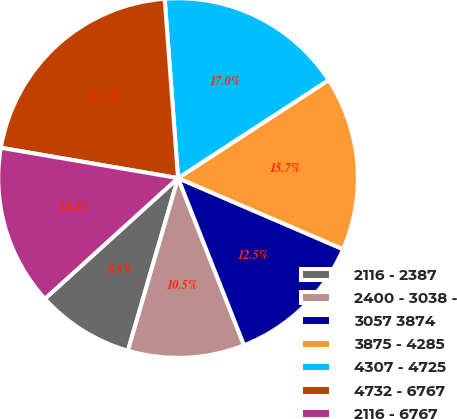Convert chart. <chart><loc_0><loc_0><loc_500><loc_500><pie_chart><fcel>2116 - 2387<fcel>2400 - 3038 -<fcel>3057 3874<fcel>3875 - 4285<fcel>4307 - 4725<fcel>4732 - 6767<fcel>2116 - 6767<nl><fcel>8.78%<fcel>10.48%<fcel>12.54%<fcel>15.66%<fcel>17.0%<fcel>21.12%<fcel>14.42%<nl></chart> 